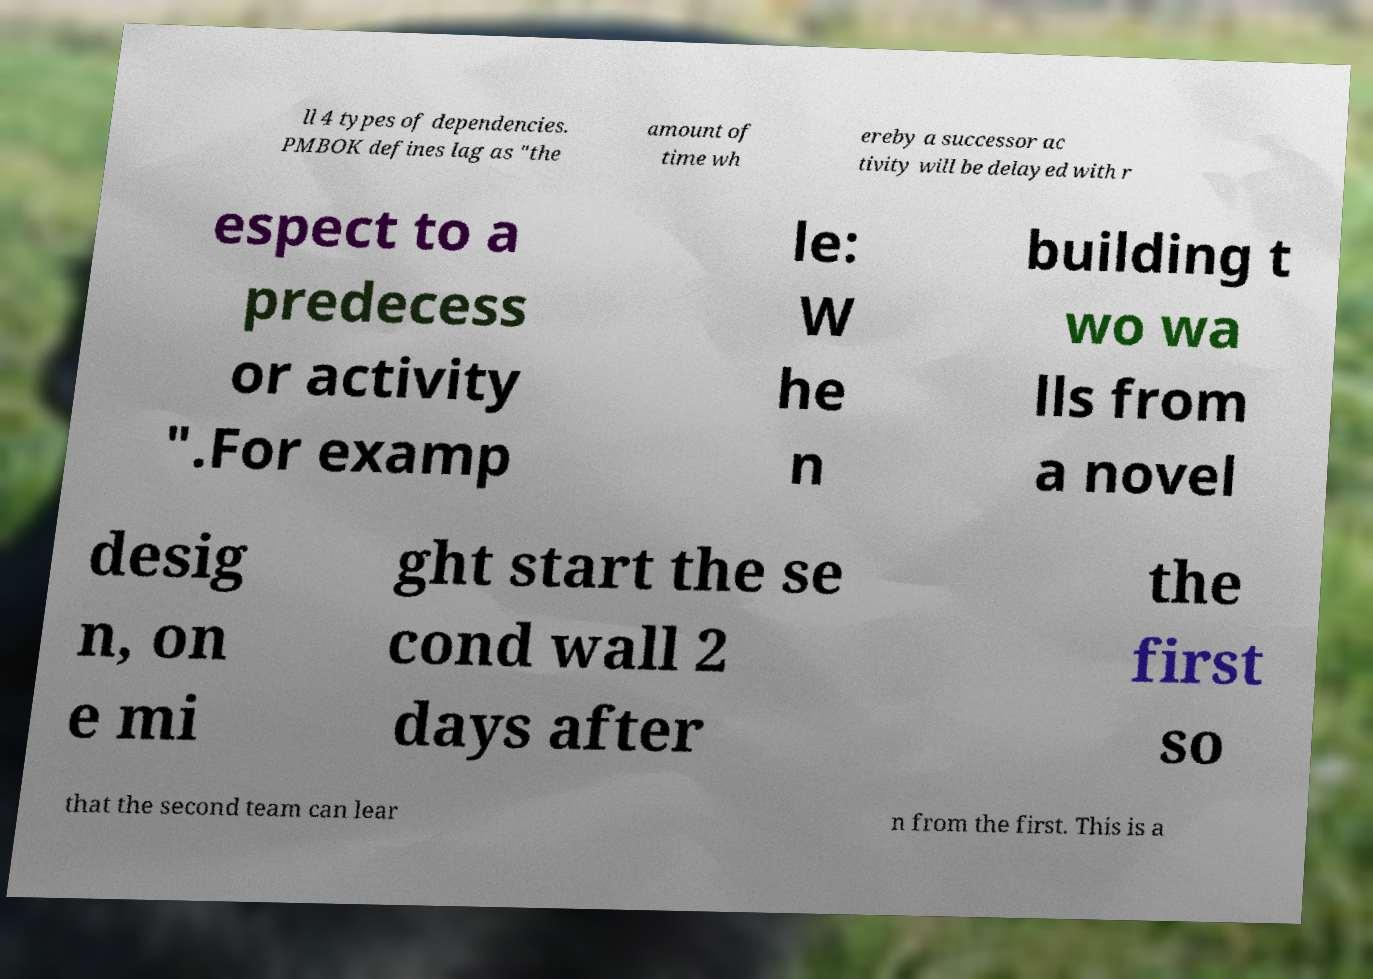Could you extract and type out the text from this image? ll 4 types of dependencies. PMBOK defines lag as "the amount of time wh ereby a successor ac tivity will be delayed with r espect to a predecess or activity ".For examp le: W he n building t wo wa lls from a novel desig n, on e mi ght start the se cond wall 2 days after the first so that the second team can lear n from the first. This is a 